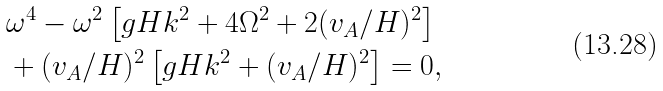Convert formula to latex. <formula><loc_0><loc_0><loc_500><loc_500>& \omega ^ { 4 } - \omega ^ { 2 } \left [ g H k ^ { 2 } + 4 \Omega ^ { 2 } + 2 ( v _ { A } / H ) ^ { 2 } \right ] \\ & + ( v _ { A } / H ) ^ { 2 } \left [ g H k ^ { 2 } + ( v _ { A } / H ) ^ { 2 } \right ] = 0 , \\</formula> 